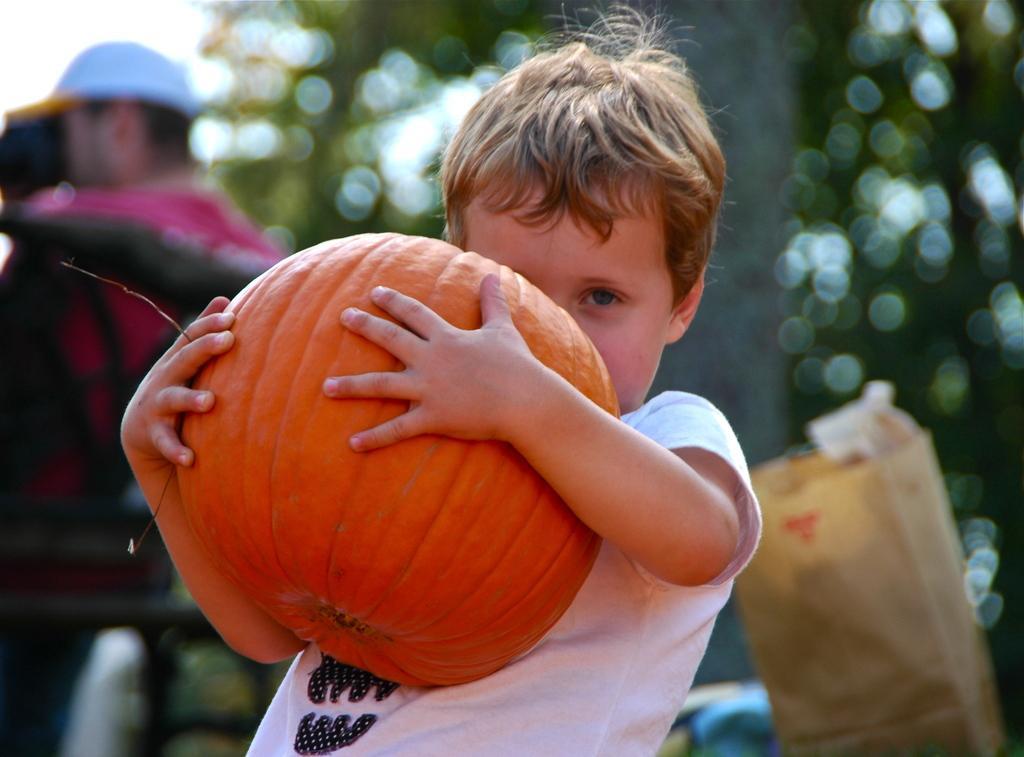Could you give a brief overview of what you see in this image? As we can see in the image there is a boy wearing white color t shirt and holding pumpkin. In the background there are few people, trees and sky. The background is little blurred. 